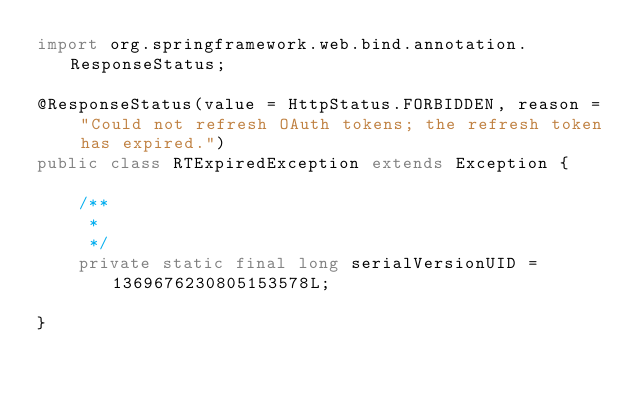<code> <loc_0><loc_0><loc_500><loc_500><_Java_>import org.springframework.web.bind.annotation.ResponseStatus;

@ResponseStatus(value = HttpStatus.FORBIDDEN, reason = "Could not refresh OAuth tokens; the refresh token has expired.")
public class RTExpiredException extends Exception {

	/**
	 * 
	 */
	private static final long serialVersionUID = 1369676230805153578L;

}
</code> 